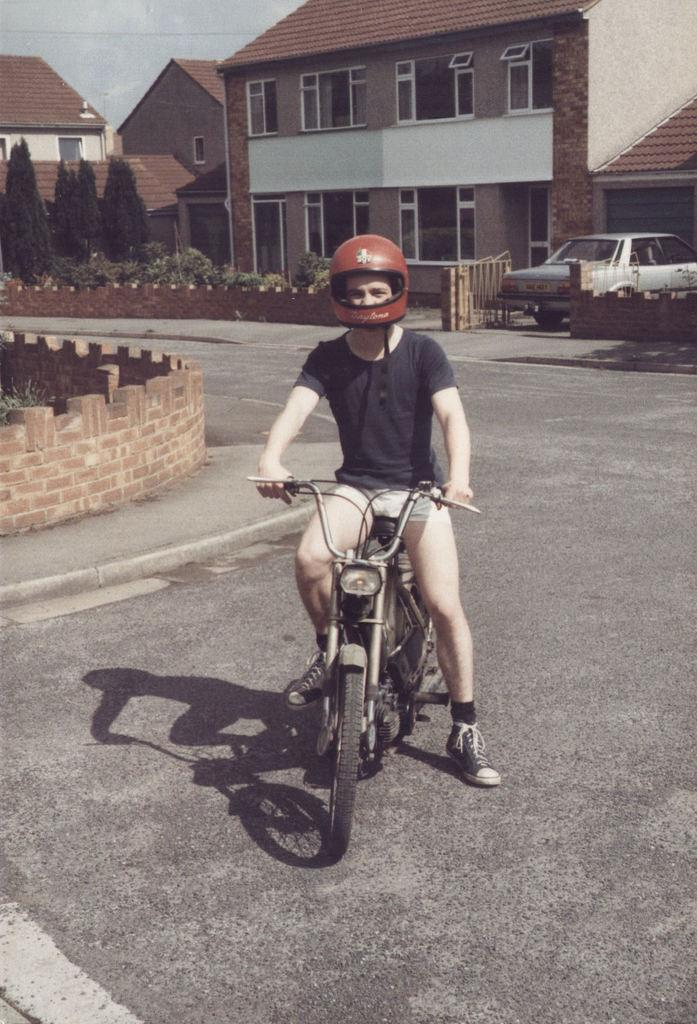Who is in the image? There is a guy in the image. What is the guy wearing on his head? The guy is wearing a helmet. What is the guy sitting on in the image? The guy is sitting on an old bike. What can be seen in the background of the image? There is a vehicle, small houses, and trees in the background of the image. What is the girl teaching in the image? There is no girl present in the image, so it is not possible to determine what she might be teaching. 